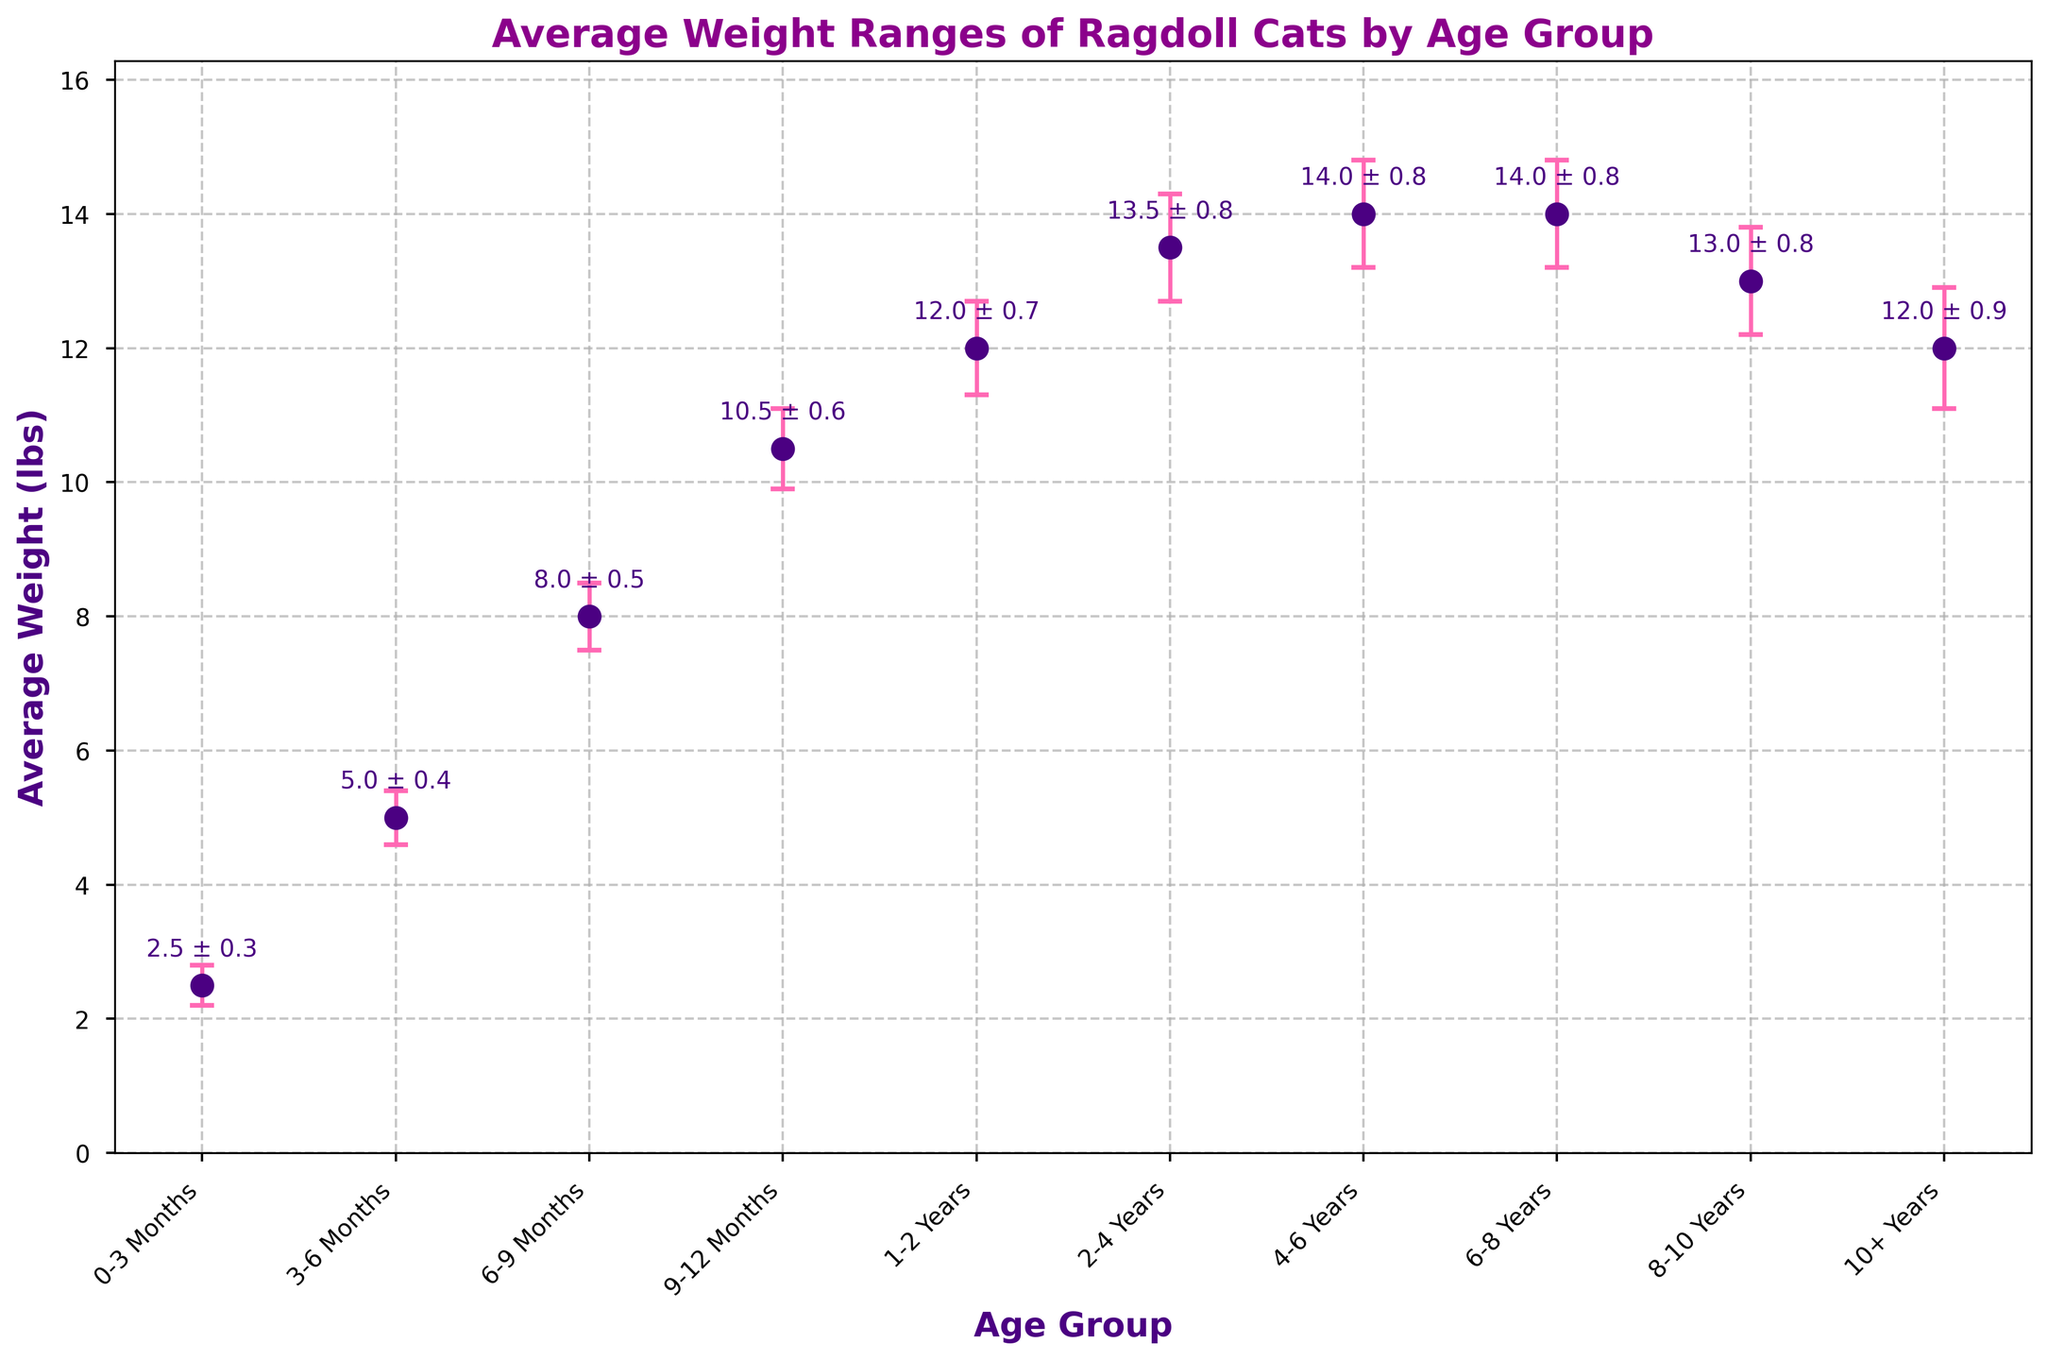What is the title of the figure? The title is located at the top of the figure and describes the main topic of the plot. It is usually a concise summary of the data being shown.
Answer: Average Weight Ranges of Ragdoll Cats by Age Group Which age group has the highest average weight? Look for the age group with the highest dot on the y-axis, which represents the average weight.
Answer: 4-6 Years and 6-8 Years What is the average weight of Ragdoll cats aged 9-12 months? Find the dot corresponding to the age group 9-12 Months along the x-axis and read the y-axis value.
Answer: 10.5 lbs What is the age group with the smallest error margin? Examine the vertical error bars and identify the one with the smallest height, representing the smallest error margin.
Answer: 0-3 Months How does the average weight change from 1-2 years to 10+ years? Compare the y-axis values for the age groups 1-2 Years and 10+ Years to determine if the weight increases, decreases, or stays the same.
Answer: It decreases from 12.0 lbs to 12.0 lbs What is the difference in the average weight between Ragdoll cats aged 8-10 years and those aged 6-8 years? Find the average weights for the age groups 8-10 Years and 6-8 Years, then subtract the weight of the former from the latter.
Answer: 1.0 lbs Which age group has an error margin of 0.7 lbs? Look for the age group on the x-axis where the error bar has a length that corresponds to 0.7 lbs.
Answer: 1-2 Years What is the average weight and its error margin for Ragdoll cats aged 3-6 months? Find the dot at the age group 3-6 Months, and read the values for the average weight and the length of the error bar.
Answer: 5.0 lbs ± 0.4 lbs Does the average weight of Ragdoll cats increase or decrease as they age beyond 8 years? Compare the average weights of the age groups 8-10 Years and 10+ Years to observe the trend.
Answer: It decreases 